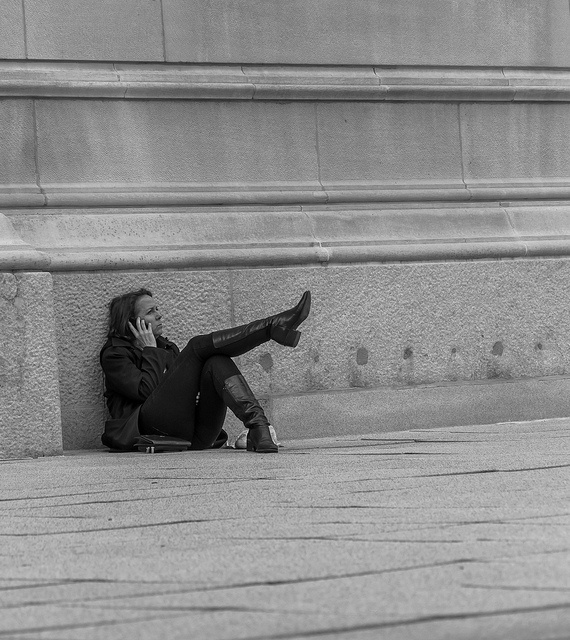Describe the objects in this image and their specific colors. I can see people in darkgray, black, gray, and lightgray tones, handbag in black and darkgray tones, handbag in black, gray, and darkgray tones, and cell phone in black and darkgray tones in this image. 